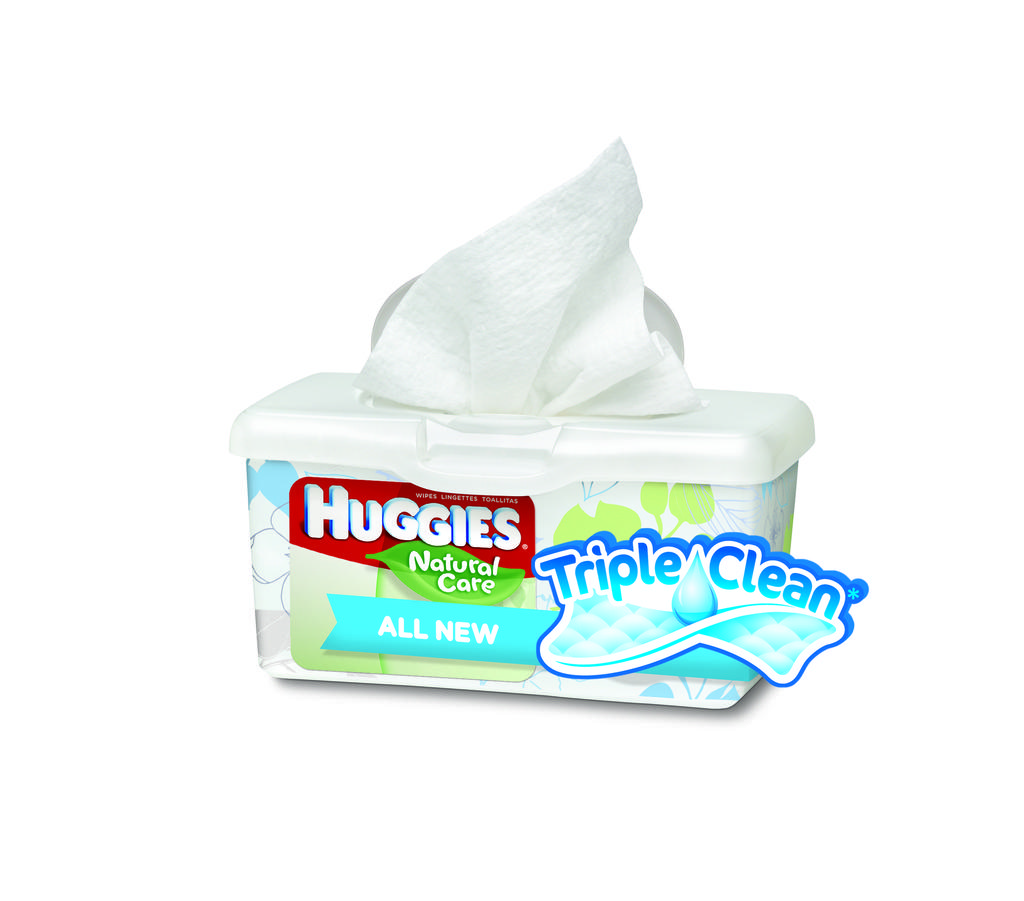What type of product is shown in the image? There are Huggies baby wipes in the image. How are the baby wipes packaged? The baby wipes are in a white box. What type of acoustics can be heard from the baby wipes in the image? There is no sound or acoustics associated with the baby wipes in the image. What type of dress is featured on the baby wipes in the image? There is no dress or clothing item featured on the baby wipes in the image. 